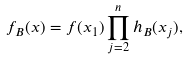<formula> <loc_0><loc_0><loc_500><loc_500>f _ { B } ( x ) = f ( x _ { 1 } ) \prod _ { j = 2 } ^ { n } h _ { B } ( x _ { j } ) ,</formula> 